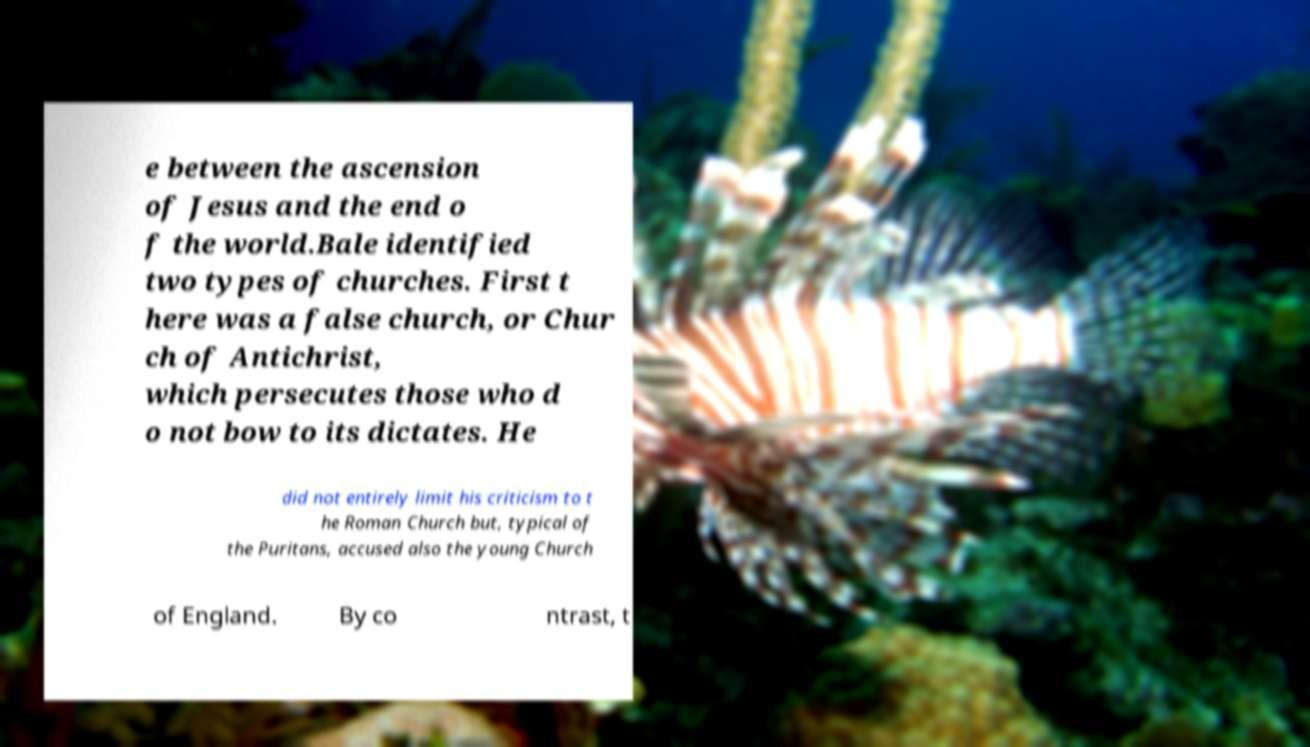Please read and relay the text visible in this image. What does it say? e between the ascension of Jesus and the end o f the world.Bale identified two types of churches. First t here was a false church, or Chur ch of Antichrist, which persecutes those who d o not bow to its dictates. He did not entirely limit his criticism to t he Roman Church but, typical of the Puritans, accused also the young Church of England. By co ntrast, t 